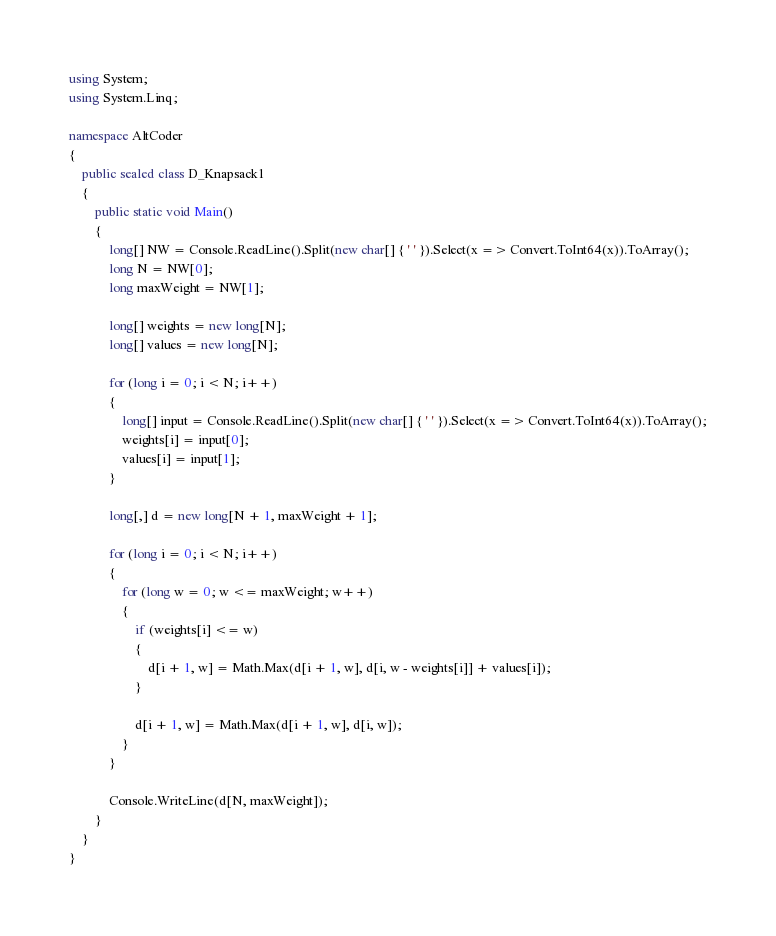<code> <loc_0><loc_0><loc_500><loc_500><_C#_>using System;
using System.Linq;

namespace AltCoder
{
    public sealed class D_Knapsack1
    {
        public static void Main()
        {
            long[] NW = Console.ReadLine().Split(new char[] { ' ' }).Select(x => Convert.ToInt64(x)).ToArray();
            long N = NW[0];
            long maxWeight = NW[1];

            long[] weights = new long[N];
            long[] values = new long[N];

            for (long i = 0; i < N; i++)
            {
                long[] input = Console.ReadLine().Split(new char[] { ' ' }).Select(x => Convert.ToInt64(x)).ToArray();
                weights[i] = input[0];
                values[i] = input[1];
            }

            long[,] d = new long[N + 1, maxWeight + 1];

            for (long i = 0; i < N; i++)
            {
                for (long w = 0; w <= maxWeight; w++)
                {
                    if (weights[i] <= w)
                    {
                        d[i + 1, w] = Math.Max(d[i + 1, w], d[i, w - weights[i]] + values[i]);
                    }

                    d[i + 1, w] = Math.Max(d[i + 1, w], d[i, w]);
                }
            }

            Console.WriteLine(d[N, maxWeight]);
        }
    }
}
</code> 